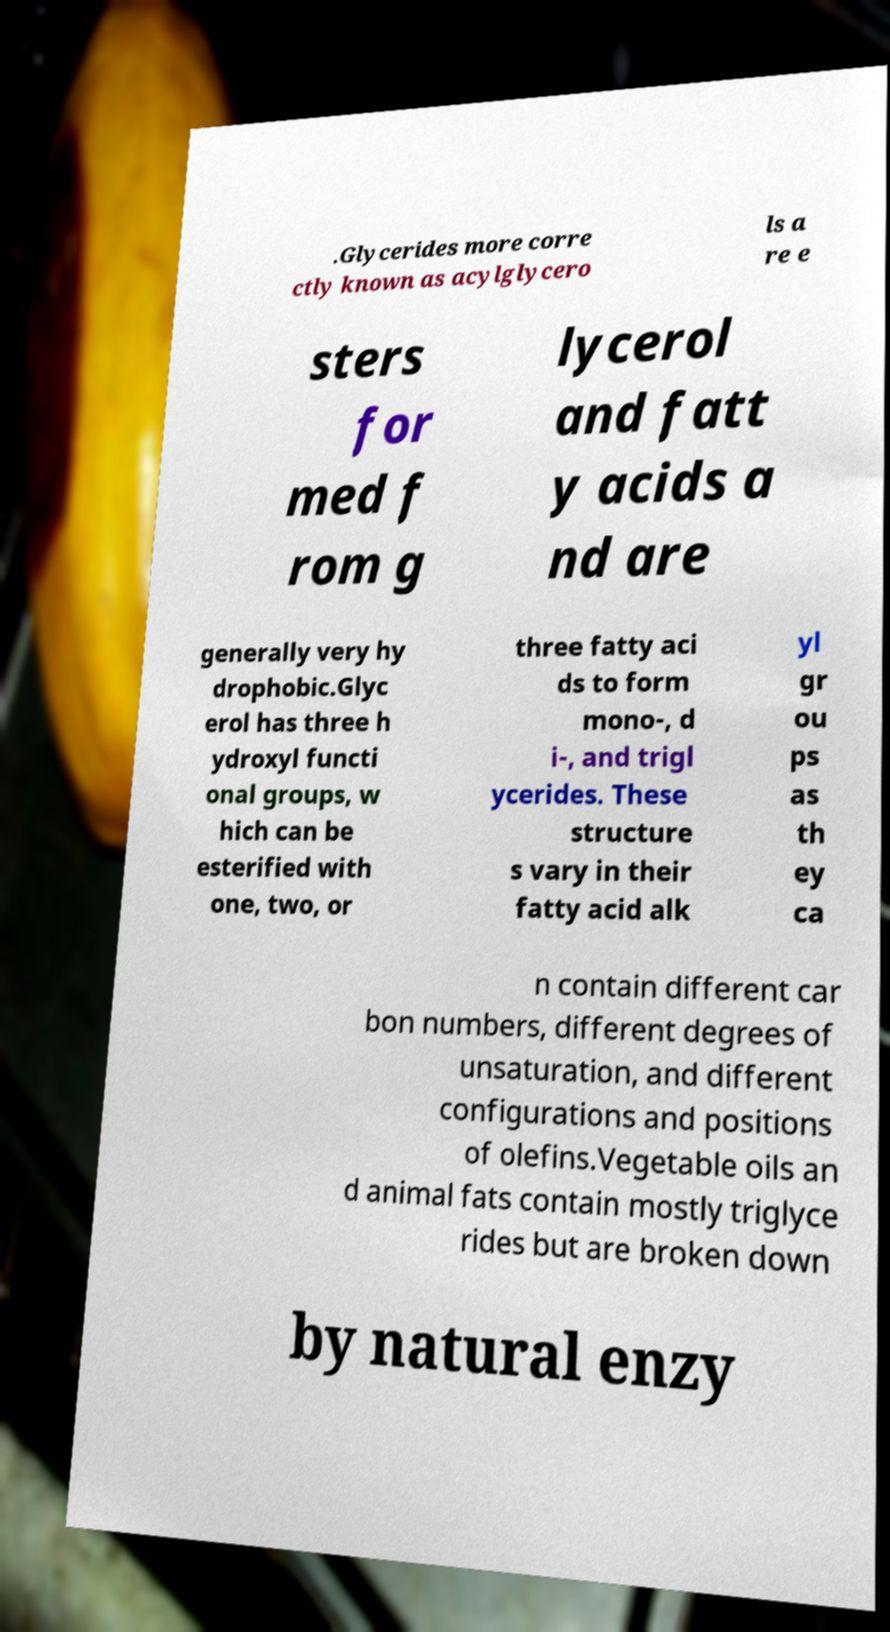Can you read and provide the text displayed in the image?This photo seems to have some interesting text. Can you extract and type it out for me? .Glycerides more corre ctly known as acylglycero ls a re e sters for med f rom g lycerol and fatt y acids a nd are generally very hy drophobic.Glyc erol has three h ydroxyl functi onal groups, w hich can be esterified with one, two, or three fatty aci ds to form mono-, d i-, and trigl ycerides. These structure s vary in their fatty acid alk yl gr ou ps as th ey ca n contain different car bon numbers, different degrees of unsaturation, and different configurations and positions of olefins.Vegetable oils an d animal fats contain mostly triglyce rides but are broken down by natural enzy 